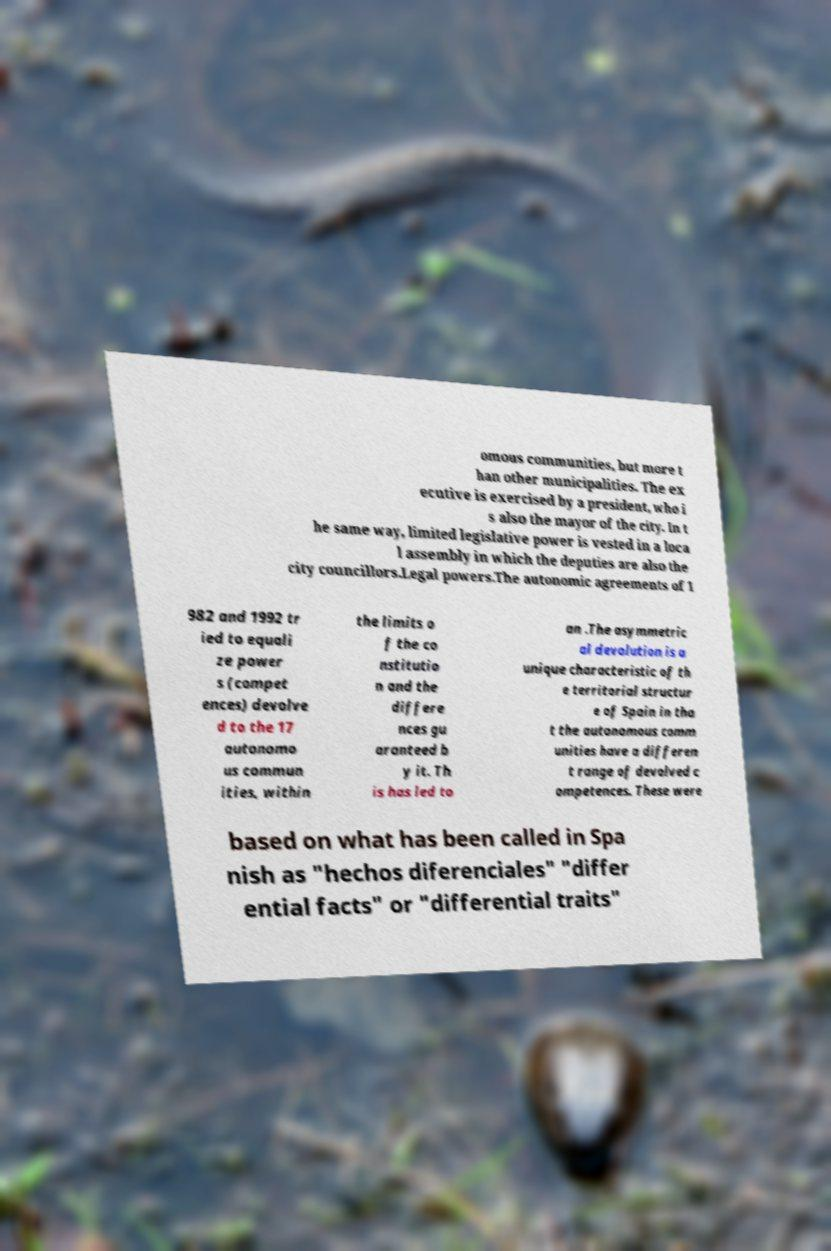Can you accurately transcribe the text from the provided image for me? omous communities, but more t han other municipalities. The ex ecutive is exercised by a president, who i s also the mayor of the city. In t he same way, limited legislative power is vested in a loca l assembly in which the deputies are also the city councillors.Legal powers.The autonomic agreements of 1 982 and 1992 tr ied to equali ze power s (compet ences) devolve d to the 17 autonomo us commun ities, within the limits o f the co nstitutio n and the differe nces gu aranteed b y it. Th is has led to an .The asymmetric al devolution is a unique characteristic of th e territorial structur e of Spain in tha t the autonomous comm unities have a differen t range of devolved c ompetences. These were based on what has been called in Spa nish as "hechos diferenciales" "differ ential facts" or "differential traits" 